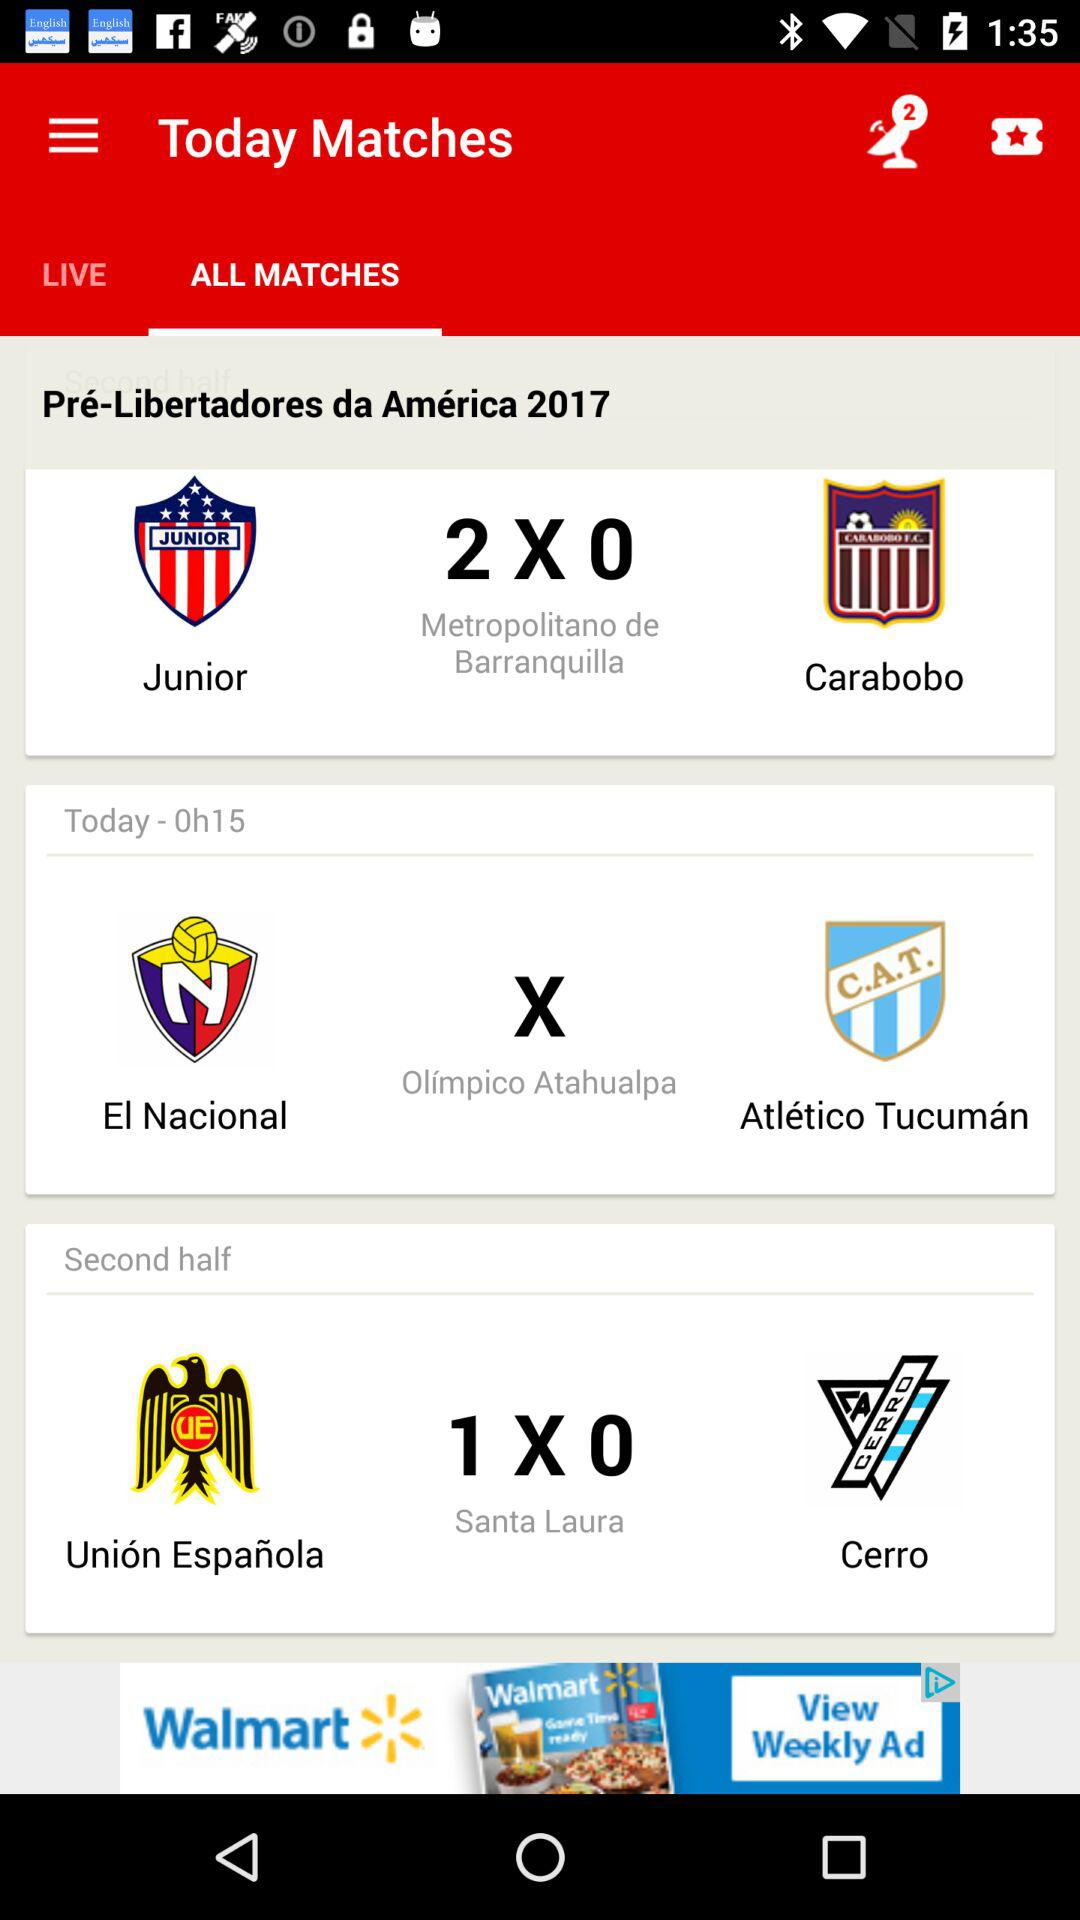How many matches are in the second half?
Answer the question using a single word or phrase. 1 